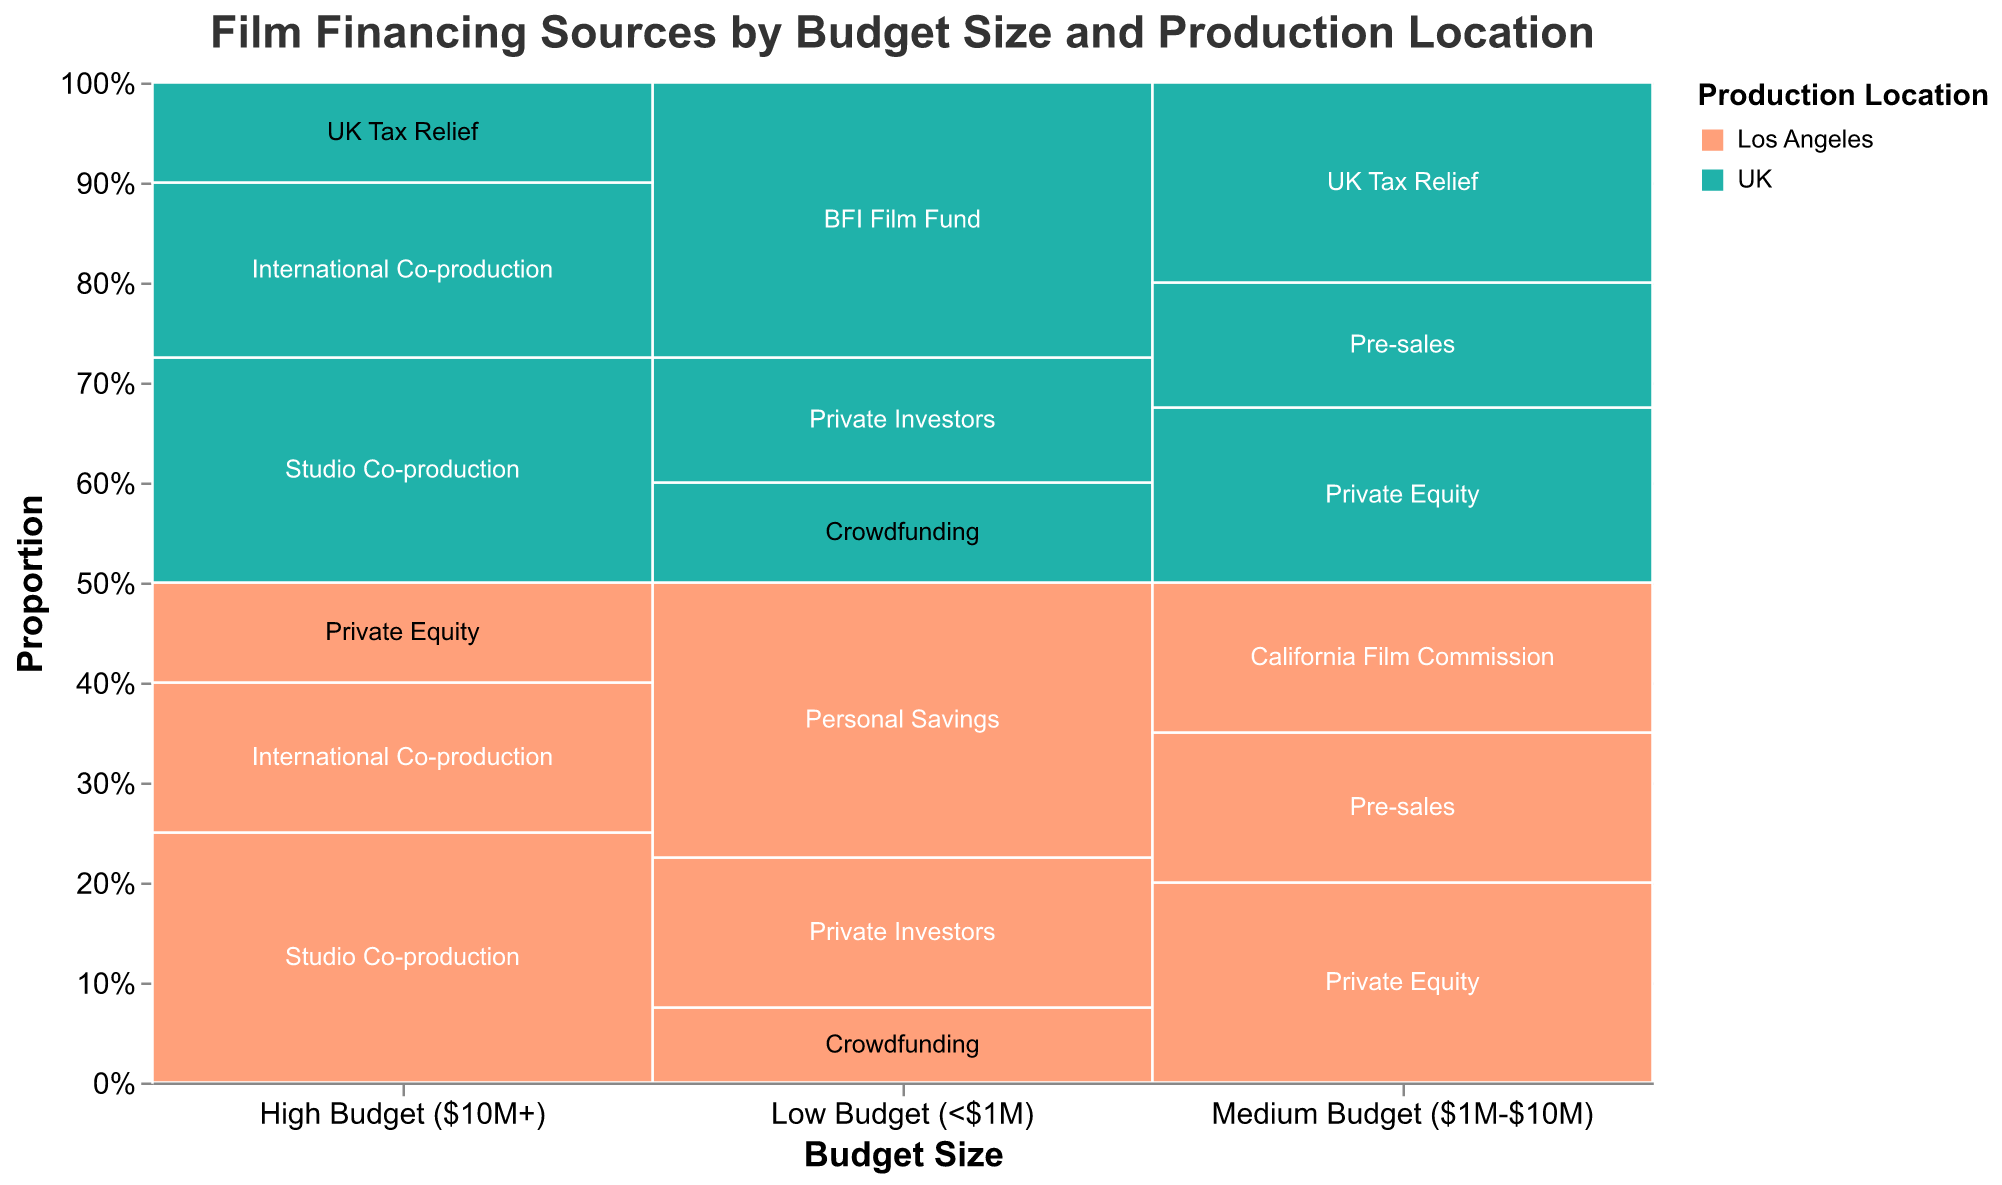What is the title of the figure? The title is usually displayed at the top of the figure. By looking at the top, we can read the text that gives us the title.
Answer: Film Financing Sources by Budget Size and Production Location How is the Budget Size represented in the plot? The Budget Size is shown along the horizontal axis (x-axis) of the plot. Different categories of budget sizes are labeled below each respective section.
Answer: Horizontal axis Which financing source is most common for low-budget films in Los Angeles? By looking at the section labeled 'Low Budget (<$1M)' and its sub-bars, we see that 'Personal Savings' has the largest vertical extent, indicating the highest percentage.
Answer: Personal Savings What percentage of medium-budget films in the UK are financed through UK Tax Relief? In the section 'Medium Budget ($1M-$10M)', find the bar labeled 'UK'. The block labeled 'UK Tax Relief' occupies 40% of the space.
Answer: 40% Compare the most common financing source for high-budget films between Los Angeles and the UK. For high-budget films in Los Angeles, the largest block is 'Studio Co-production' (50%). In the UK, it's also 'Studio Co-production' but at a slightly lower percentage (45%).
Answer: Both Studio Co-production What is the combined percentage of private equity used for medium and high-budget films in Los Angeles? Find the percentage of private equity for medium-budget (40%) and high-budget (20%) films in Los Angeles and sum them up: 40 + 20 = 60%.
Answer: 60% Which production location specializes more in crowdfunding for low-budget films? Compare the crowdfunding percentages for low-budget films between Los Angeles (15%) and the UK (20%). The UK has a higher percentage of crowdfunding.
Answer: UK Between Los Angeles and the UK, which location uses more film funds or commissions for low-budget and medium-budget films combined? For low-budget films, look at the 'Los Angeles' and 'UK' sub-sections and sum the 'California Film Commission' (0% for low) and 'BFI Film Fund' (55%) contributions. For medium-budget films, sum 'California Film Commission' (30%) and 'UK Tax Relief' (40%). Total for LA: 0 + 30 = 30%, and for UK: 55 + 40 = 95%.
Answer: UK How does the use of private investors for low-budget films differ between Los Angeles and the UK? Check the 'Private Investors' block for low-budget films. In Los Angeles, it's 30%, and in the UK, it's 25%. The difference is 5%.
Answer: Los Angeles uses 5% more Which financing source is not used in high-budget films in both Los Angeles and the UK? Review the blocks under 'High Budget ($10M+)' for both locations. Compare all blocks to identify which ones are empty. 'Crowdfunding,' 'Private Investors,' among others, are absent in both.
Answer: Crowdfunding or Private Investors 